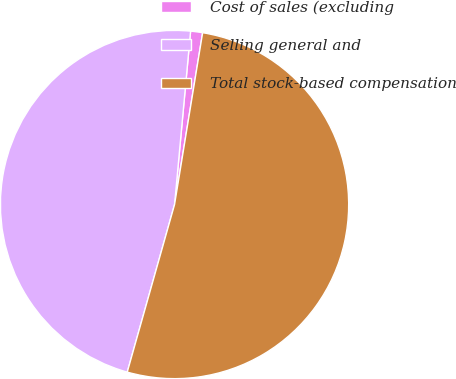Convert chart to OTSL. <chart><loc_0><loc_0><loc_500><loc_500><pie_chart><fcel>Cost of sales (excluding<fcel>Selling general and<fcel>Total stock-based compensation<nl><fcel>1.11%<fcel>47.09%<fcel>51.8%<nl></chart> 